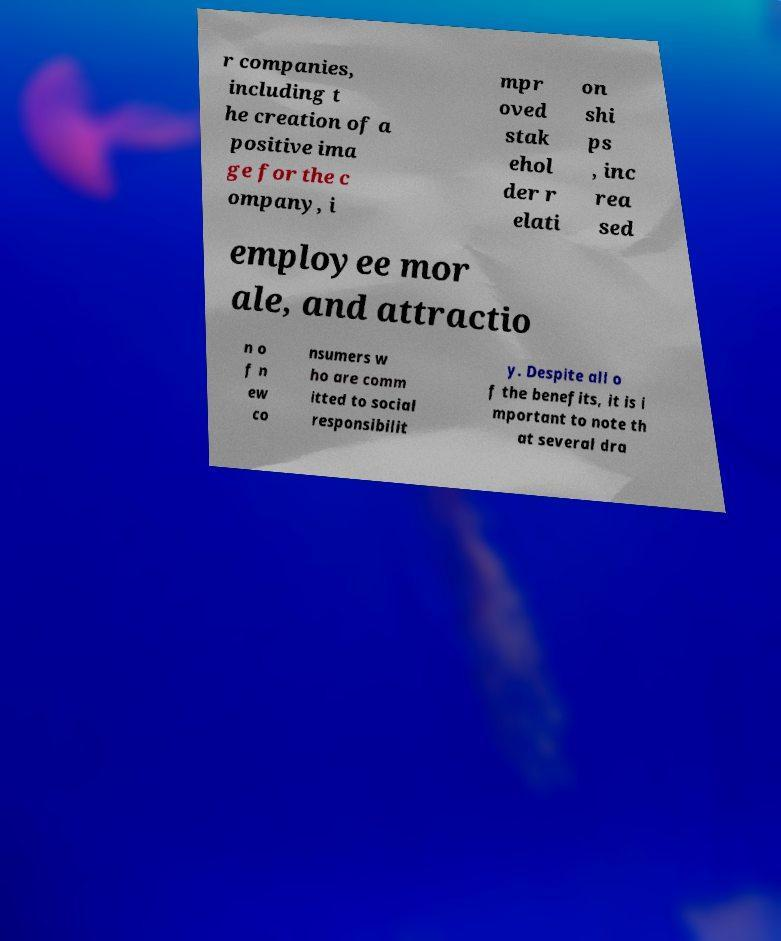For documentation purposes, I need the text within this image transcribed. Could you provide that? r companies, including t he creation of a positive ima ge for the c ompany, i mpr oved stak ehol der r elati on shi ps , inc rea sed employee mor ale, and attractio n o f n ew co nsumers w ho are comm itted to social responsibilit y. Despite all o f the benefits, it is i mportant to note th at several dra 